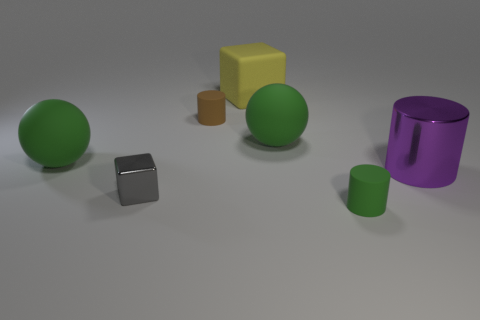There is a object that is both right of the tiny gray thing and in front of the large purple metallic thing; what shape is it? The object that is situated to the right of the tiny gray cube and in front of the large purple metallic cylinder appears to be a cylinder as well. Its color is green, and this cylindrical shape is consistent with the rounded edges and circular base that are visible from this perspective. 